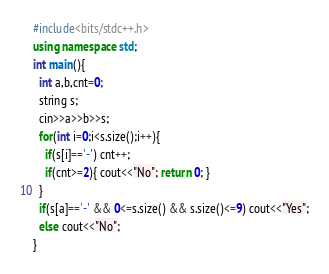<code> <loc_0><loc_0><loc_500><loc_500><_C++_>#include<bits/stdc++.h>
using namespace std;
int main(){
  int a,b,cnt=0;
  string s;
  cin>>a>>b>>s;
  for(int i=0;i<s.size();i++){
    if(s[i]=='-') cnt++;
    if(cnt>=2){ cout<<"No"; return 0; }
  }
  if(s[a]=='-' && 0<=s.size() && s.size()<=9) cout<<"Yes";
  else cout<<"No";
}
</code> 